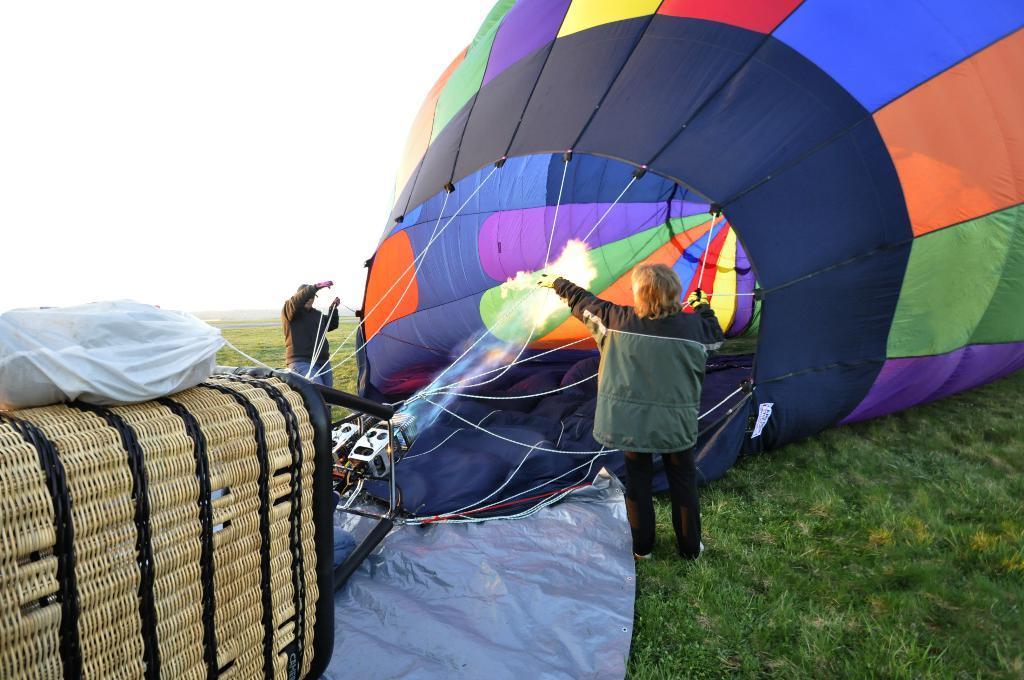Could you give a brief overview of what you see in this image? In this image we can see a man and a woman standing on the ground holding the ropes of a hot air balloon. We can also see some grass, a bag and the sky which looks cloudy. 